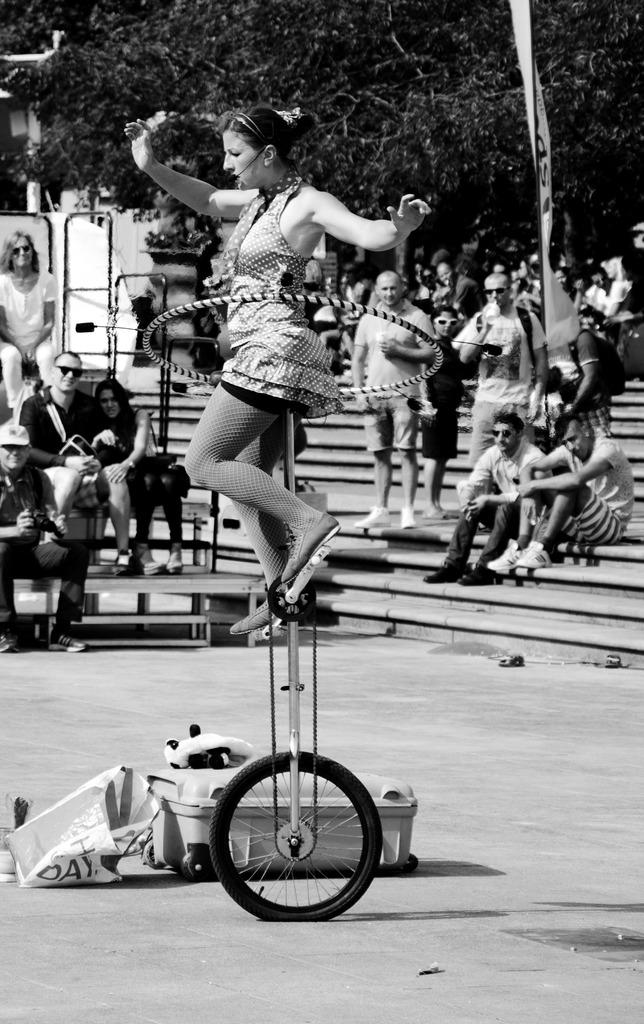What is the person in the image doing? The person is balancing on a wheel in the image. What object is visible near the person balancing on a wheel? There is a luggage bag in the image. Where are other people sitting in the image? There are people sitting on a bench and on stairs in the image. What type of trick is the person performing with the coach in the image? There is no coach present in the image, and the person is not performing a trick; they are balancing on a wheel. 